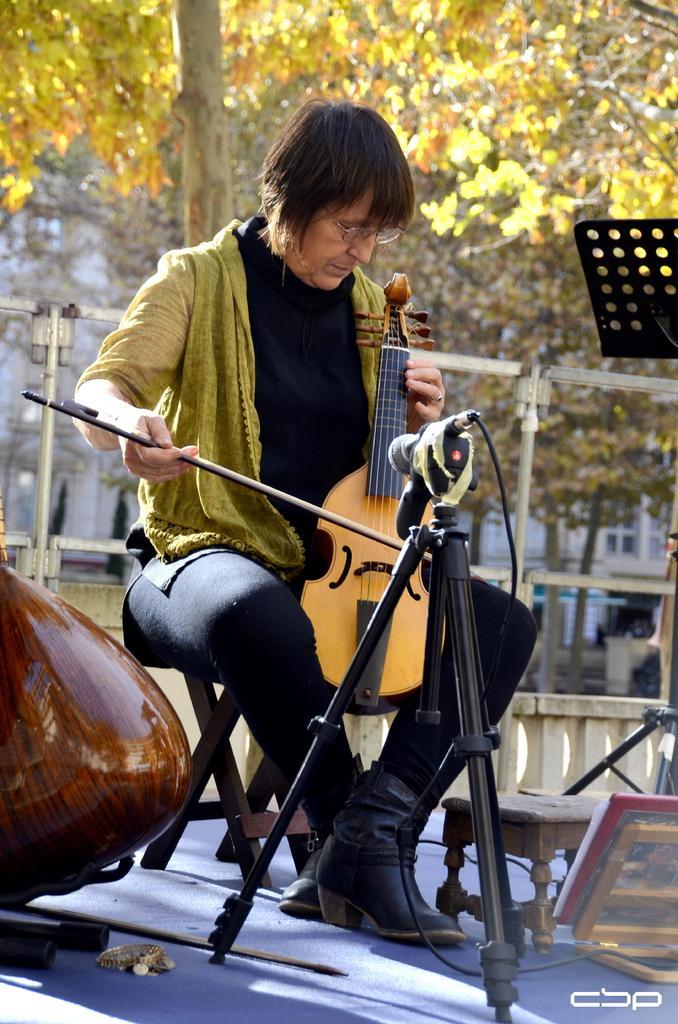Can you describe this image briefly? In the middle of the image a man is sitting on a chair and playing violin, Behind him there is a tree. In the middle of the image there is a microphone. 